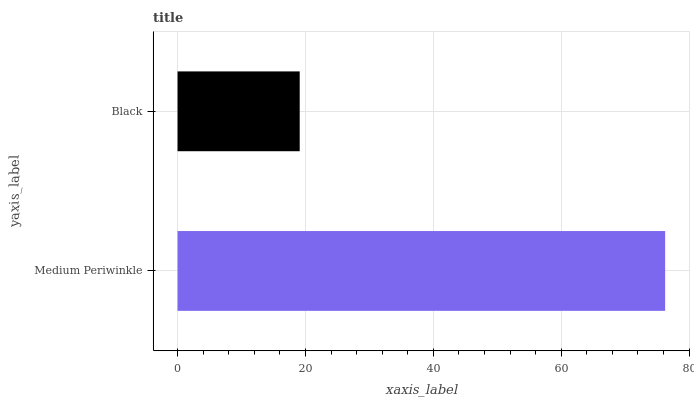Is Black the minimum?
Answer yes or no. Yes. Is Medium Periwinkle the maximum?
Answer yes or no. Yes. Is Black the maximum?
Answer yes or no. No. Is Medium Periwinkle greater than Black?
Answer yes or no. Yes. Is Black less than Medium Periwinkle?
Answer yes or no. Yes. Is Black greater than Medium Periwinkle?
Answer yes or no. No. Is Medium Periwinkle less than Black?
Answer yes or no. No. Is Medium Periwinkle the high median?
Answer yes or no. Yes. Is Black the low median?
Answer yes or no. Yes. Is Black the high median?
Answer yes or no. No. Is Medium Periwinkle the low median?
Answer yes or no. No. 